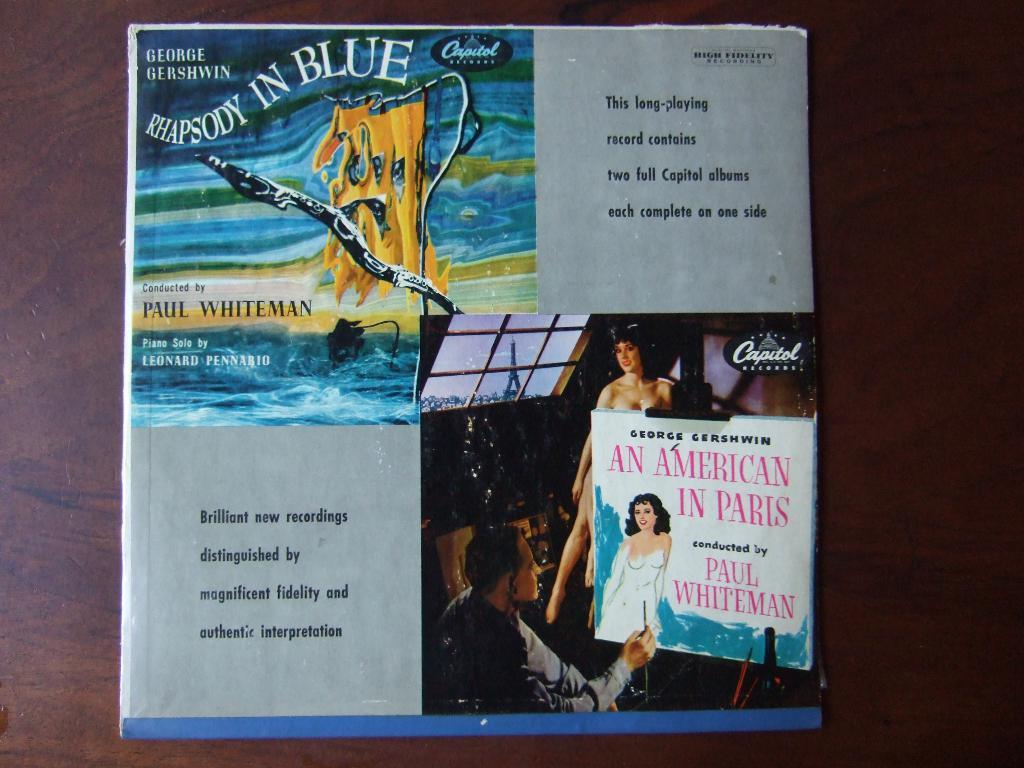Provide a one-sentence caption for the provided image. An album cover that it Titled Rhapsody in Blue. 